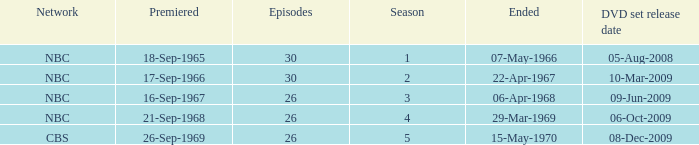When dis cbs release the DVD set? 08-Dec-2009. Would you mind parsing the complete table? {'header': ['Network', 'Premiered', 'Episodes', 'Season', 'Ended', 'DVD set release date'], 'rows': [['NBC', '18-Sep-1965', '30', '1', '07-May-1966', '05-Aug-2008'], ['NBC', '17-Sep-1966', '30', '2', '22-Apr-1967', '10-Mar-2009'], ['NBC', '16-Sep-1967', '26', '3', '06-Apr-1968', '09-Jun-2009'], ['NBC', '21-Sep-1968', '26', '4', '29-Mar-1969', '06-Oct-2009'], ['CBS', '26-Sep-1969', '26', '5', '15-May-1970', '08-Dec-2009']]} 